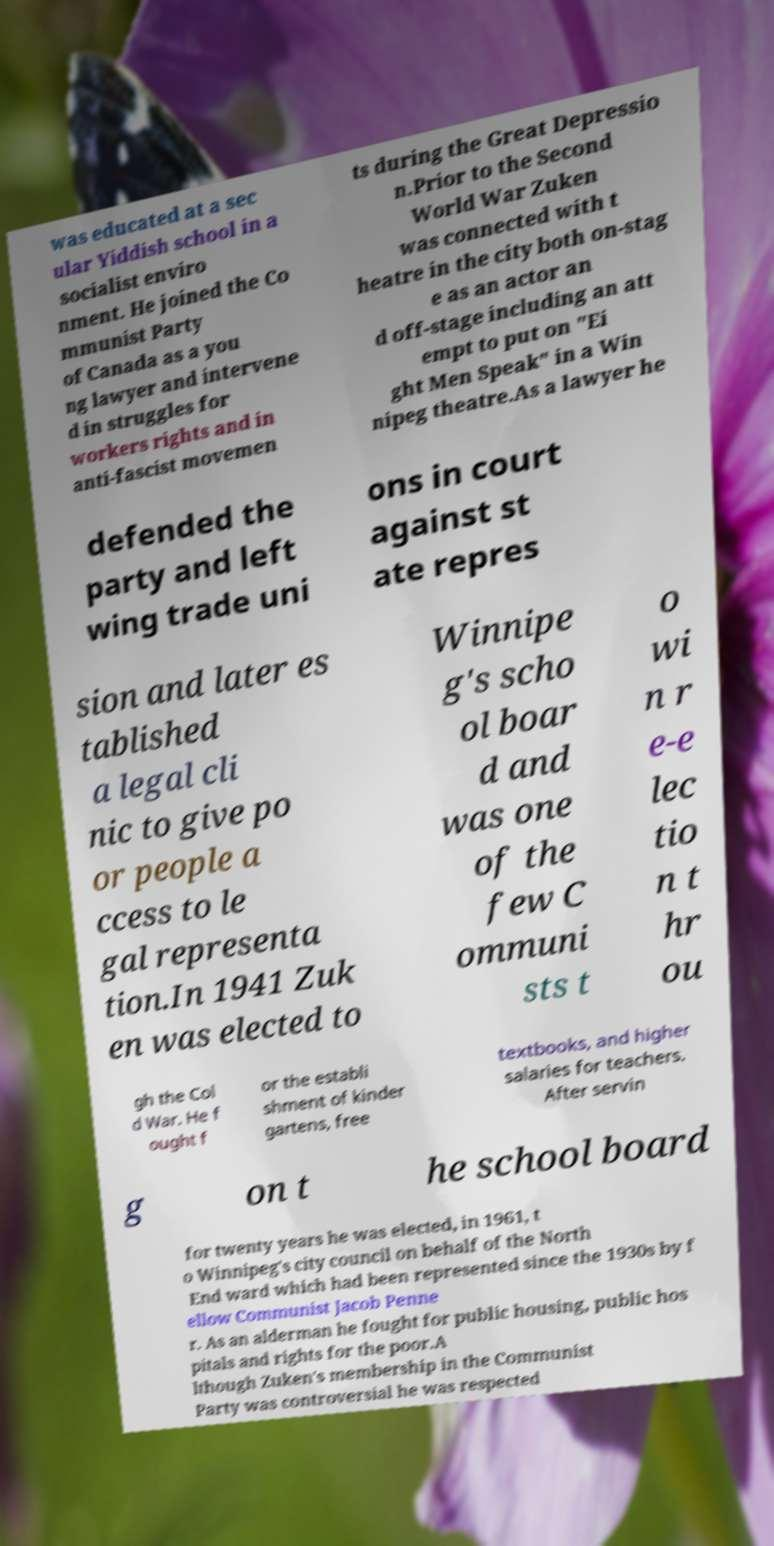I need the written content from this picture converted into text. Can you do that? was educated at a sec ular Yiddish school in a socialist enviro nment. He joined the Co mmunist Party of Canada as a you ng lawyer and intervene d in struggles for workers rights and in anti-fascist movemen ts during the Great Depressio n.Prior to the Second World War Zuken was connected with t heatre in the city both on-stag e as an actor an d off-stage including an att empt to put on "Ei ght Men Speak" in a Win nipeg theatre.As a lawyer he defended the party and left wing trade uni ons in court against st ate repres sion and later es tablished a legal cli nic to give po or people a ccess to le gal representa tion.In 1941 Zuk en was elected to Winnipe g's scho ol boar d and was one of the few C ommuni sts t o wi n r e-e lec tio n t hr ou gh the Col d War. He f ought f or the establi shment of kinder gartens, free textbooks, and higher salaries for teachers. After servin g on t he school board for twenty years he was elected, in 1961, t o Winnipeg's city council on behalf of the North End ward which had been represented since the 1930s by f ellow Communist Jacob Penne r. As an alderman he fought for public housing, public hos pitals and rights for the poor.A lthough Zuken's membership in the Communist Party was controversial he was respected 